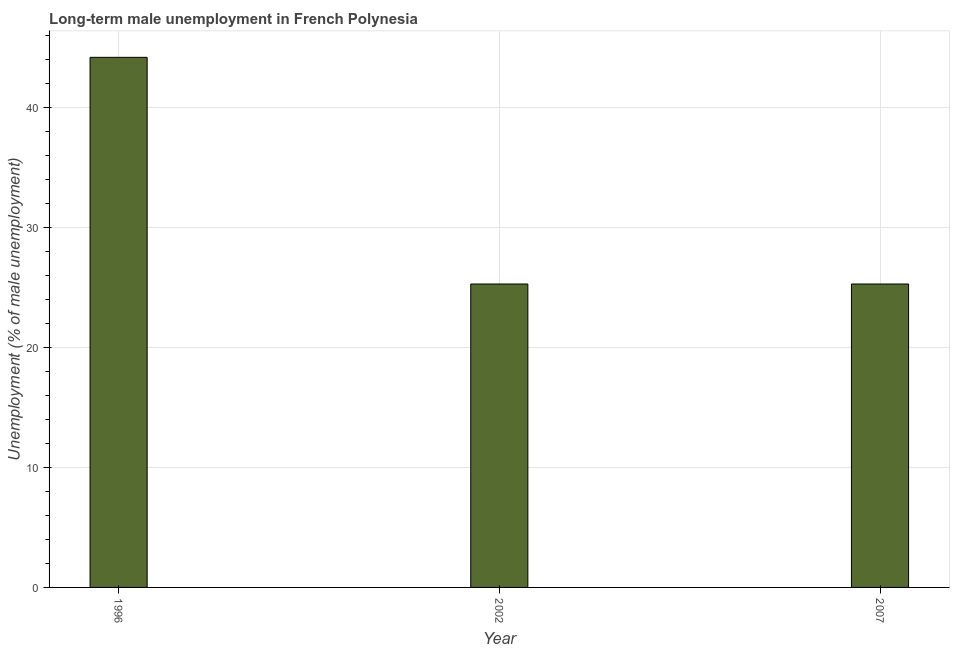Does the graph contain grids?
Provide a short and direct response. Yes. What is the title of the graph?
Ensure brevity in your answer.  Long-term male unemployment in French Polynesia. What is the label or title of the Y-axis?
Give a very brief answer. Unemployment (% of male unemployment). What is the long-term male unemployment in 1996?
Make the answer very short. 44.2. Across all years, what is the maximum long-term male unemployment?
Make the answer very short. 44.2. Across all years, what is the minimum long-term male unemployment?
Ensure brevity in your answer.  25.3. What is the sum of the long-term male unemployment?
Make the answer very short. 94.8. What is the difference between the long-term male unemployment in 1996 and 2007?
Your answer should be very brief. 18.9. What is the average long-term male unemployment per year?
Ensure brevity in your answer.  31.6. What is the median long-term male unemployment?
Your response must be concise. 25.3. Do a majority of the years between 2002 and 2007 (inclusive) have long-term male unemployment greater than 8 %?
Provide a short and direct response. Yes. What is the ratio of the long-term male unemployment in 1996 to that in 2002?
Your answer should be very brief. 1.75. Is the difference between the long-term male unemployment in 1996 and 2007 greater than the difference between any two years?
Make the answer very short. Yes. What is the difference between the highest and the second highest long-term male unemployment?
Give a very brief answer. 18.9. In how many years, is the long-term male unemployment greater than the average long-term male unemployment taken over all years?
Provide a succinct answer. 1. How many bars are there?
Make the answer very short. 3. What is the Unemployment (% of male unemployment) of 1996?
Offer a terse response. 44.2. What is the Unemployment (% of male unemployment) of 2002?
Your response must be concise. 25.3. What is the Unemployment (% of male unemployment) in 2007?
Provide a short and direct response. 25.3. What is the difference between the Unemployment (% of male unemployment) in 1996 and 2002?
Your answer should be very brief. 18.9. What is the difference between the Unemployment (% of male unemployment) in 1996 and 2007?
Ensure brevity in your answer.  18.9. What is the difference between the Unemployment (% of male unemployment) in 2002 and 2007?
Provide a succinct answer. 0. What is the ratio of the Unemployment (% of male unemployment) in 1996 to that in 2002?
Give a very brief answer. 1.75. What is the ratio of the Unemployment (% of male unemployment) in 1996 to that in 2007?
Provide a succinct answer. 1.75. What is the ratio of the Unemployment (% of male unemployment) in 2002 to that in 2007?
Offer a terse response. 1. 